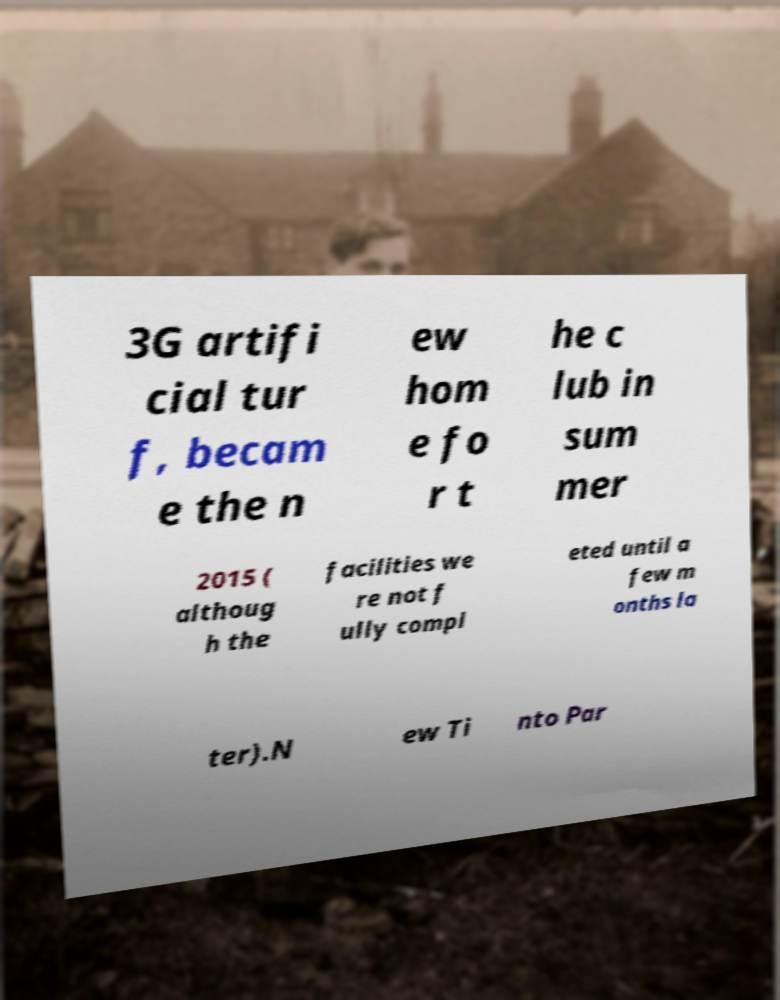Could you extract and type out the text from this image? 3G artifi cial tur f, becam e the n ew hom e fo r t he c lub in sum mer 2015 ( althoug h the facilities we re not f ully compl eted until a few m onths la ter).N ew Ti nto Par 